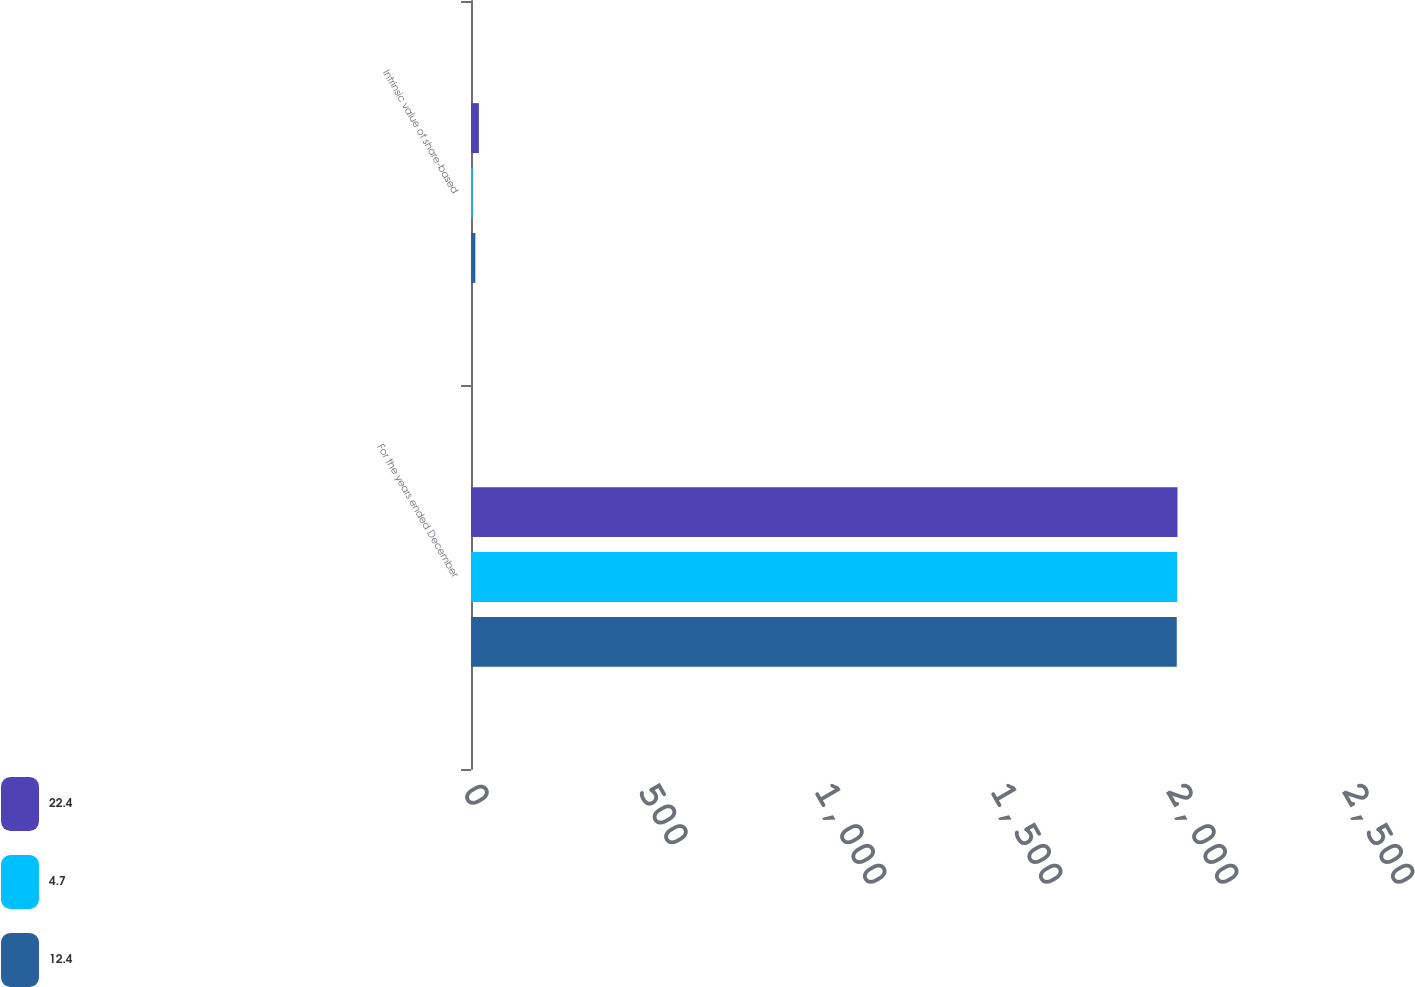Convert chart. <chart><loc_0><loc_0><loc_500><loc_500><stacked_bar_chart><ecel><fcel>For the years ended December<fcel>Intrinsic value of share-based<nl><fcel>22.4<fcel>2007<fcel>22.4<nl><fcel>4.7<fcel>2006<fcel>4.7<nl><fcel>12.4<fcel>2005<fcel>12.4<nl></chart> 